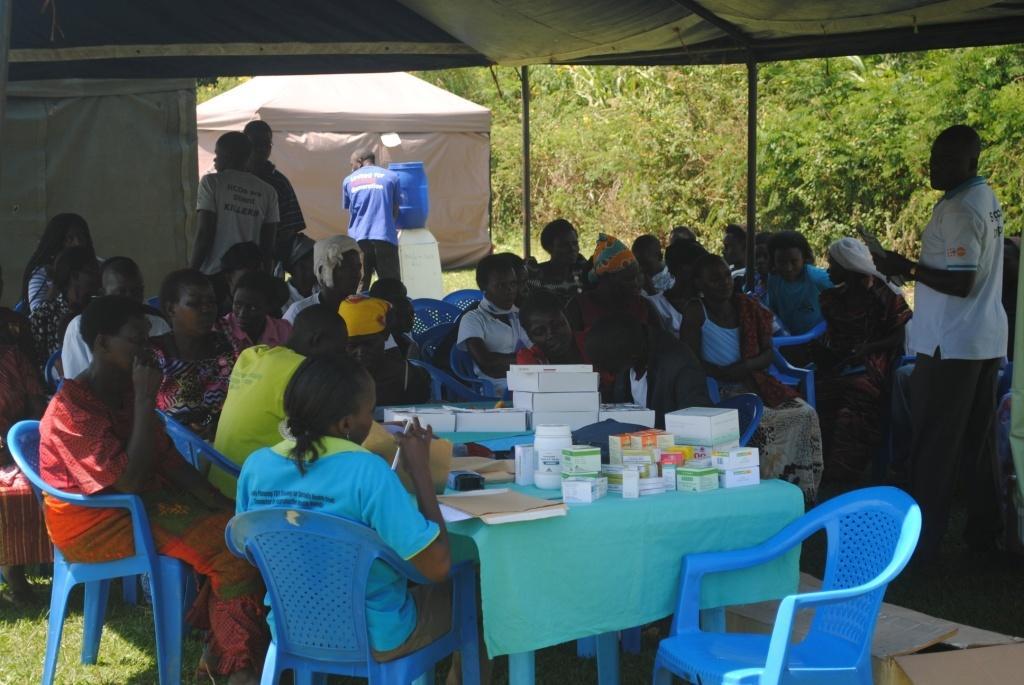Describe this image in one or two sentences. In this picture there are some people sitting in the chairs on a table on which some medicines and books were placed. There are women and men in this group and some children. One guy is standing here. In the background there are some tents, water tins and some trays here. 